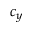Convert formula to latex. <formula><loc_0><loc_0><loc_500><loc_500>c _ { y }</formula> 